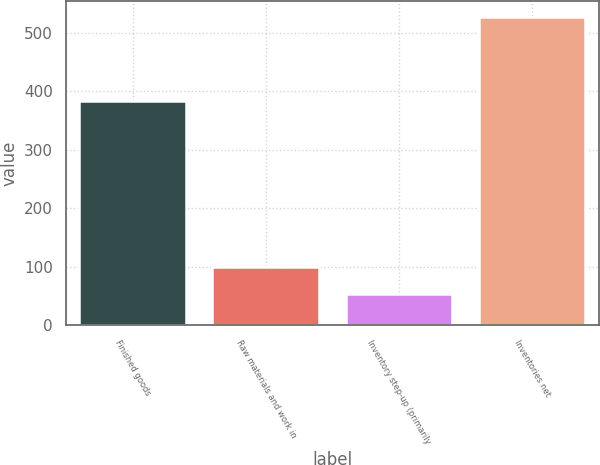<chart> <loc_0><loc_0><loc_500><loc_500><bar_chart><fcel>Finished goods<fcel>Raw materials and work in<fcel>Inventory step-up (primarily<fcel>Inventories net<nl><fcel>384.3<fcel>100.11<fcel>52.6<fcel>527.7<nl></chart> 